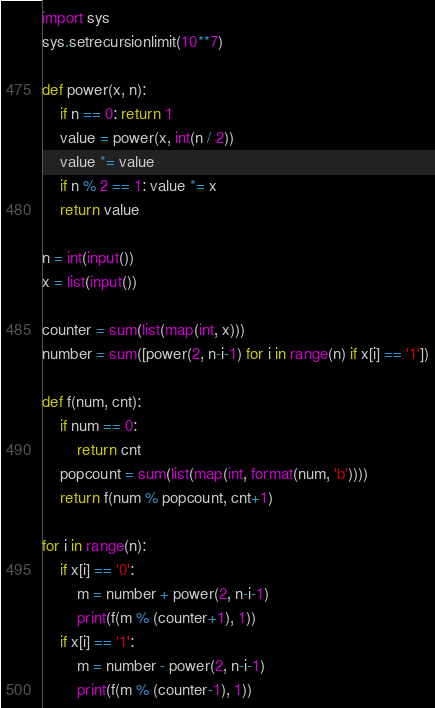Convert code to text. <code><loc_0><loc_0><loc_500><loc_500><_Python_>import sys
sys.setrecursionlimit(10**7)

def power(x, n):
    if n == 0: return 1
    value = power(x, int(n / 2))
    value *= value
    if n % 2 == 1: value *= x
    return value

n = int(input())
x = list(input())

counter = sum(list(map(int, x)))
number = sum([power(2, n-i-1) for i in range(n) if x[i] == '1'])

def f(num, cnt):
    if num == 0:
        return cnt
    popcount = sum(list(map(int, format(num, 'b'))))
    return f(num % popcount, cnt+1)

for i in range(n):
    if x[i] == '0':
        m = number + power(2, n-i-1)
        print(f(m % (counter+1), 1))
    if x[i] == '1':
        m = number - power(2, n-i-1)
        print(f(m % (counter-1), 1))
</code> 